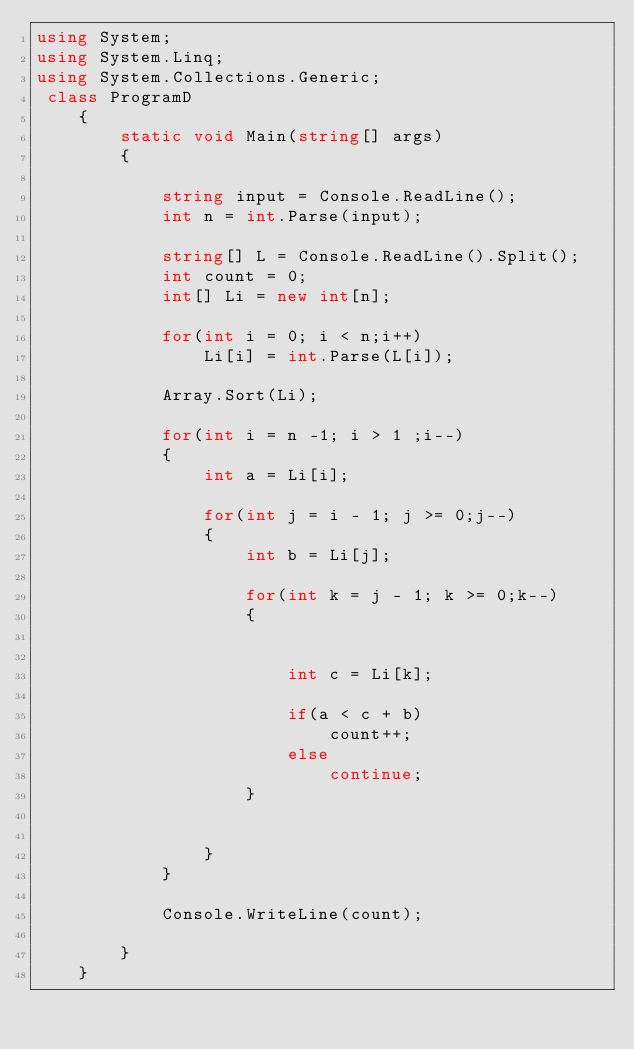<code> <loc_0><loc_0><loc_500><loc_500><_C#_>using System;
using System.Linq;
using System.Collections.Generic;
 class ProgramD
    {
        static void Main(string[] args)
        {
            
            string input = Console.ReadLine();
            int n = int.Parse(input);

            string[] L = Console.ReadLine().Split();
            int count = 0;
            int[] Li = new int[n];

            for(int i = 0; i < n;i++)
                Li[i] = int.Parse(L[i]);
            
            Array.Sort(Li);

            for(int i = n -1; i > 1 ;i--)
            {
                int a = Li[i];

                for(int j = i - 1; j >= 0;j--)
                {
                    int b = Li[j];

                    for(int k = j - 1; k >= 0;k--)
                    {
                
                
                        int c = Li[k];

                        if(a < c + b)
                            count++;
                        else
                            continue;
                    }


                }
            }

            Console.WriteLine(count);
                
        }
    }</code> 